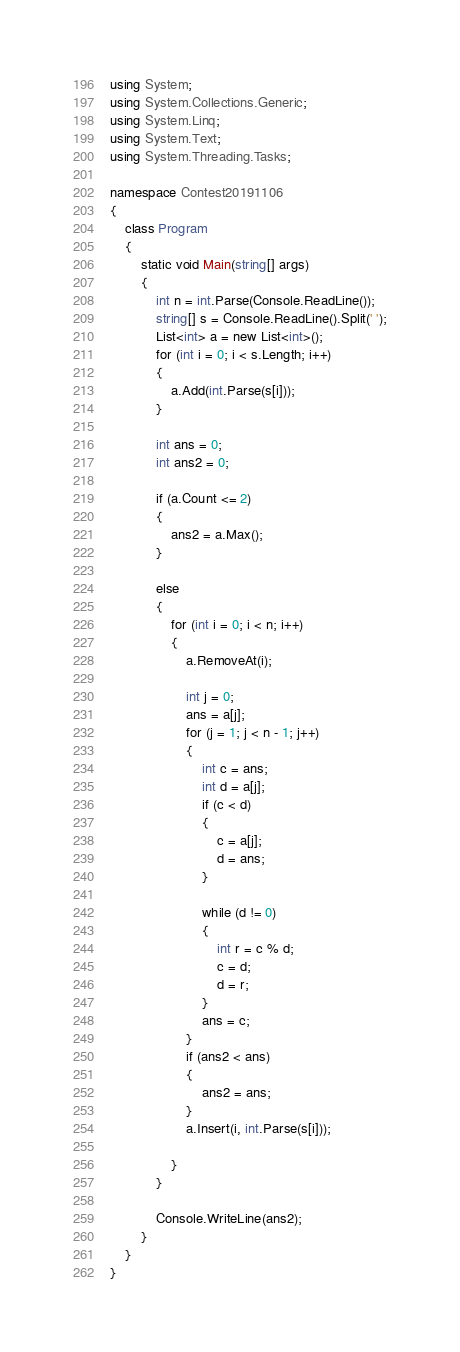<code> <loc_0><loc_0><loc_500><loc_500><_C#_>using System;
using System.Collections.Generic;
using System.Linq;
using System.Text;
using System.Threading.Tasks;

namespace Contest20191106
{
    class Program
    {
        static void Main(string[] args)
        {
            int n = int.Parse(Console.ReadLine());
            string[] s = Console.ReadLine().Split(' ');
            List<int> a = new List<int>();
            for (int i = 0; i < s.Length; i++)
            {
                a.Add(int.Parse(s[i]));
            }

            int ans = 0;
            int ans2 = 0;

            if (a.Count <= 2)
            {              
                ans2 = a.Max();
            }

            else
            {
                for (int i = 0; i < n; i++)
                {
                    a.RemoveAt(i);

                    int j = 0;
                    ans = a[j];
                    for (j = 1; j < n - 1; j++) 
                    {
                        int c = ans;
                        int d = a[j];
                        if (c < d)
                        {
                            c = a[j];
                            d = ans;
                        }

                        while (d != 0)
                        {
                            int r = c % d;
                            c = d;
                            d = r;
                        }
                        ans = c;
                    }
                    if (ans2 < ans)
                    {
                        ans2 = ans;
                    }
                    a.Insert(i, int.Parse(s[i]));

                }
            }

            Console.WriteLine(ans2);
        }
    }
}
</code> 